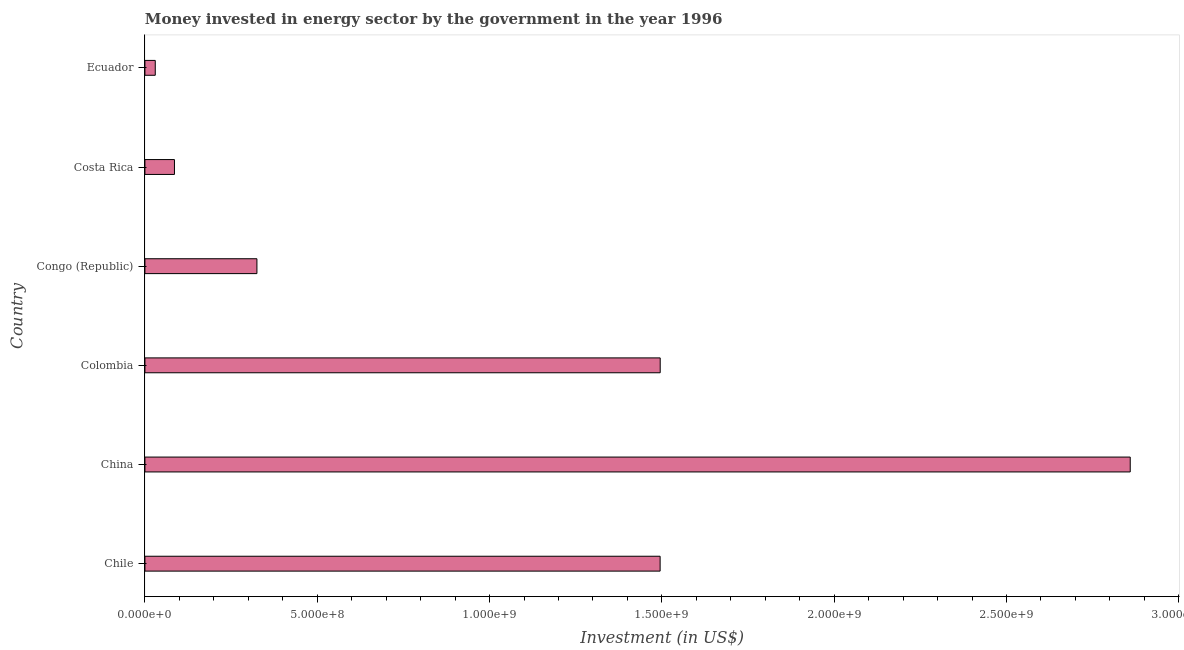Does the graph contain any zero values?
Your response must be concise. No. What is the title of the graph?
Offer a terse response. Money invested in energy sector by the government in the year 1996. What is the label or title of the X-axis?
Make the answer very short. Investment (in US$). What is the label or title of the Y-axis?
Your response must be concise. Country. What is the investment in energy in Colombia?
Your response must be concise. 1.50e+09. Across all countries, what is the maximum investment in energy?
Offer a very short reply. 2.86e+09. Across all countries, what is the minimum investment in energy?
Offer a very short reply. 3.00e+07. In which country was the investment in energy minimum?
Make the answer very short. Ecuador. What is the sum of the investment in energy?
Keep it short and to the point. 6.29e+09. What is the difference between the investment in energy in China and Ecuador?
Provide a short and direct response. 2.83e+09. What is the average investment in energy per country?
Provide a short and direct response. 1.05e+09. What is the median investment in energy?
Keep it short and to the point. 9.10e+08. What is the difference between the highest and the second highest investment in energy?
Your response must be concise. 1.36e+09. Is the sum of the investment in energy in China and Ecuador greater than the maximum investment in energy across all countries?
Provide a short and direct response. Yes. What is the difference between the highest and the lowest investment in energy?
Your answer should be compact. 2.83e+09. In how many countries, is the investment in energy greater than the average investment in energy taken over all countries?
Your answer should be very brief. 3. How many bars are there?
Offer a very short reply. 6. What is the difference between two consecutive major ticks on the X-axis?
Provide a short and direct response. 5.00e+08. Are the values on the major ticks of X-axis written in scientific E-notation?
Your response must be concise. Yes. What is the Investment (in US$) in Chile?
Provide a succinct answer. 1.50e+09. What is the Investment (in US$) of China?
Your response must be concise. 2.86e+09. What is the Investment (in US$) of Colombia?
Offer a terse response. 1.50e+09. What is the Investment (in US$) of Congo (Republic)?
Offer a very short reply. 3.25e+08. What is the Investment (in US$) of Costa Rica?
Provide a succinct answer. 8.57e+07. What is the Investment (in US$) of Ecuador?
Offer a terse response. 3.00e+07. What is the difference between the Investment (in US$) in Chile and China?
Offer a very short reply. -1.36e+09. What is the difference between the Investment (in US$) in Chile and Colombia?
Your answer should be very brief. -2.00e+05. What is the difference between the Investment (in US$) in Chile and Congo (Republic)?
Ensure brevity in your answer.  1.17e+09. What is the difference between the Investment (in US$) in Chile and Costa Rica?
Ensure brevity in your answer.  1.41e+09. What is the difference between the Investment (in US$) in Chile and Ecuador?
Give a very brief answer. 1.46e+09. What is the difference between the Investment (in US$) in China and Colombia?
Keep it short and to the point. 1.36e+09. What is the difference between the Investment (in US$) in China and Congo (Republic)?
Offer a terse response. 2.53e+09. What is the difference between the Investment (in US$) in China and Costa Rica?
Offer a very short reply. 2.77e+09. What is the difference between the Investment (in US$) in China and Ecuador?
Keep it short and to the point. 2.83e+09. What is the difference between the Investment (in US$) in Colombia and Congo (Republic)?
Provide a succinct answer. 1.17e+09. What is the difference between the Investment (in US$) in Colombia and Costa Rica?
Your answer should be very brief. 1.41e+09. What is the difference between the Investment (in US$) in Colombia and Ecuador?
Provide a succinct answer. 1.47e+09. What is the difference between the Investment (in US$) in Congo (Republic) and Costa Rica?
Make the answer very short. 2.39e+08. What is the difference between the Investment (in US$) in Congo (Republic) and Ecuador?
Your answer should be compact. 2.95e+08. What is the difference between the Investment (in US$) in Costa Rica and Ecuador?
Provide a succinct answer. 5.57e+07. What is the ratio of the Investment (in US$) in Chile to that in China?
Your answer should be very brief. 0.52. What is the ratio of the Investment (in US$) in Chile to that in Costa Rica?
Ensure brevity in your answer.  17.45. What is the ratio of the Investment (in US$) in Chile to that in Ecuador?
Offer a very short reply. 49.83. What is the ratio of the Investment (in US$) in China to that in Colombia?
Make the answer very short. 1.91. What is the ratio of the Investment (in US$) in China to that in Congo (Republic)?
Make the answer very short. 8.8. What is the ratio of the Investment (in US$) in China to that in Costa Rica?
Make the answer very short. 33.36. What is the ratio of the Investment (in US$) in China to that in Ecuador?
Your response must be concise. 95.3. What is the ratio of the Investment (in US$) in Colombia to that in Congo (Republic)?
Provide a short and direct response. 4.6. What is the ratio of the Investment (in US$) in Colombia to that in Costa Rica?
Your answer should be very brief. 17.45. What is the ratio of the Investment (in US$) in Colombia to that in Ecuador?
Make the answer very short. 49.84. What is the ratio of the Investment (in US$) in Congo (Republic) to that in Costa Rica?
Ensure brevity in your answer.  3.79. What is the ratio of the Investment (in US$) in Congo (Republic) to that in Ecuador?
Your response must be concise. 10.83. What is the ratio of the Investment (in US$) in Costa Rica to that in Ecuador?
Provide a short and direct response. 2.86. 